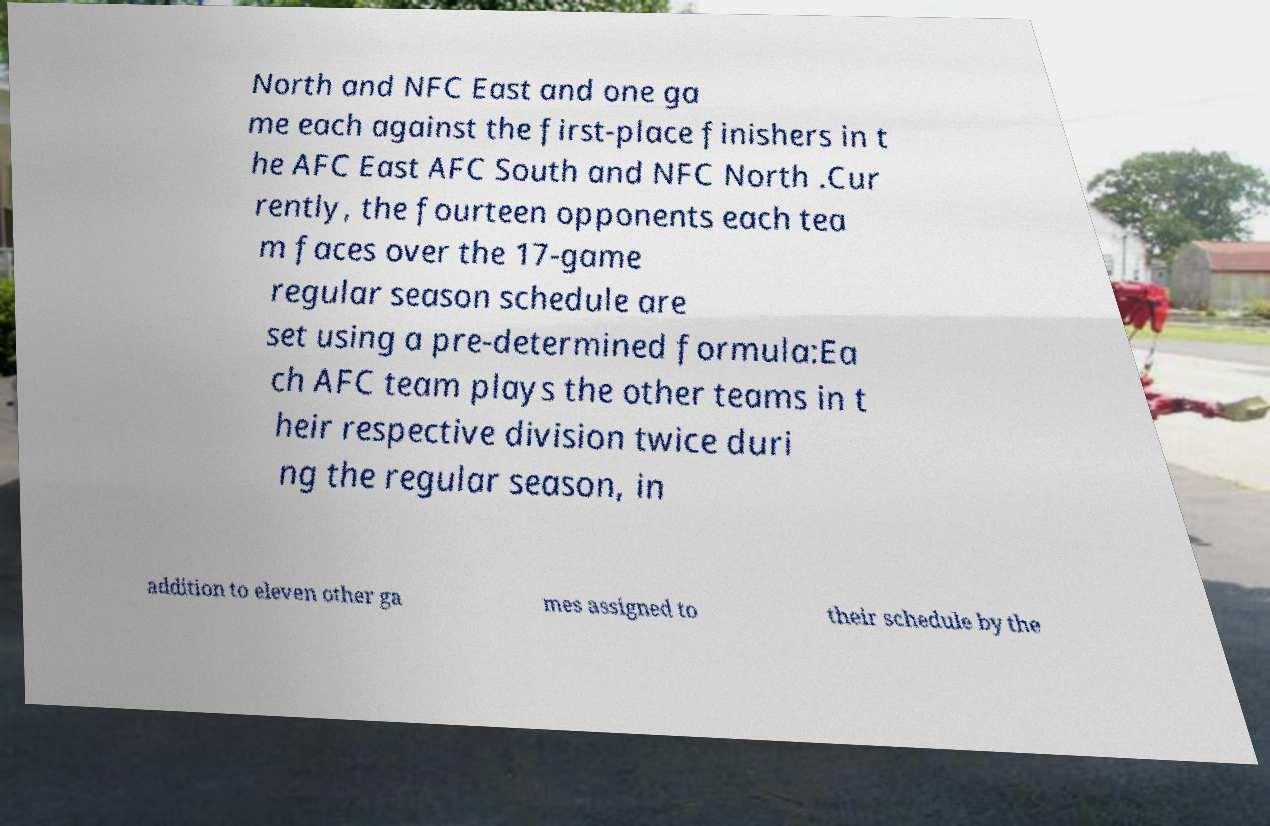Could you assist in decoding the text presented in this image and type it out clearly? North and NFC East and one ga me each against the first-place finishers in t he AFC East AFC South and NFC North .Cur rently, the fourteen opponents each tea m faces over the 17-game regular season schedule are set using a pre-determined formula:Ea ch AFC team plays the other teams in t heir respective division twice duri ng the regular season, in addition to eleven other ga mes assigned to their schedule by the 